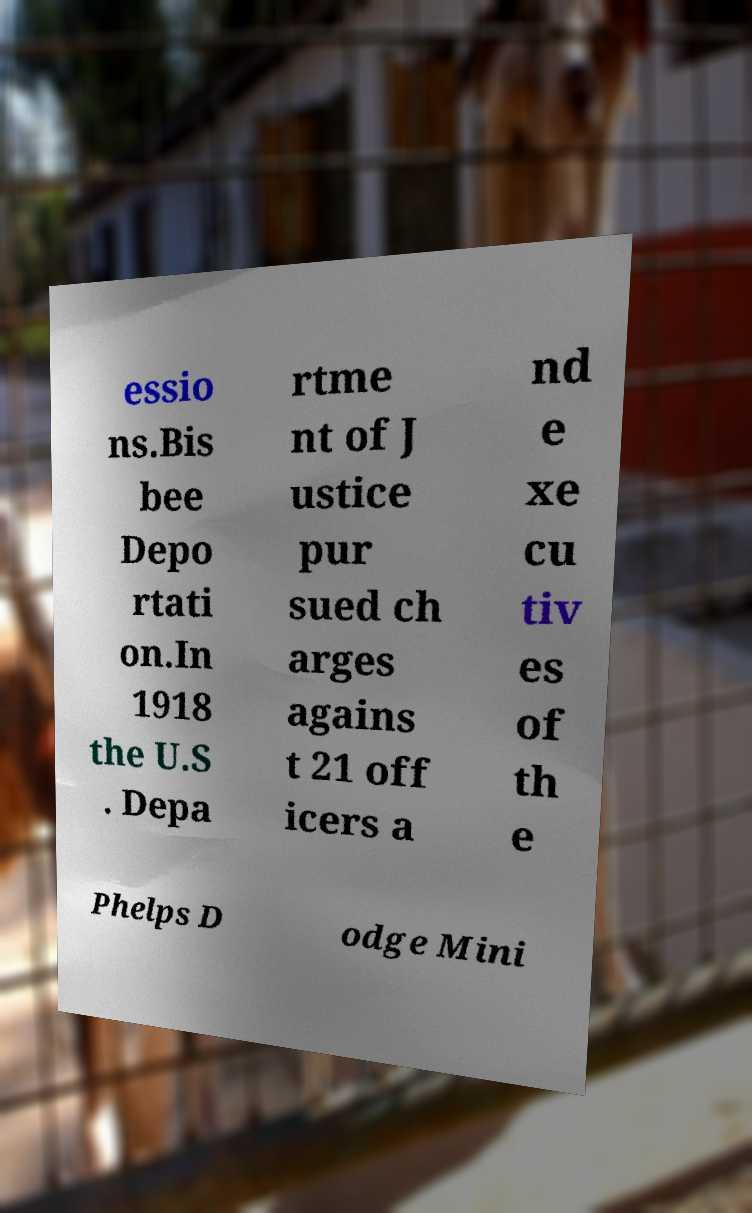Can you read and provide the text displayed in the image?This photo seems to have some interesting text. Can you extract and type it out for me? essio ns.Bis bee Depo rtati on.In 1918 the U.S . Depa rtme nt of J ustice pur sued ch arges agains t 21 off icers a nd e xe cu tiv es of th e Phelps D odge Mini 